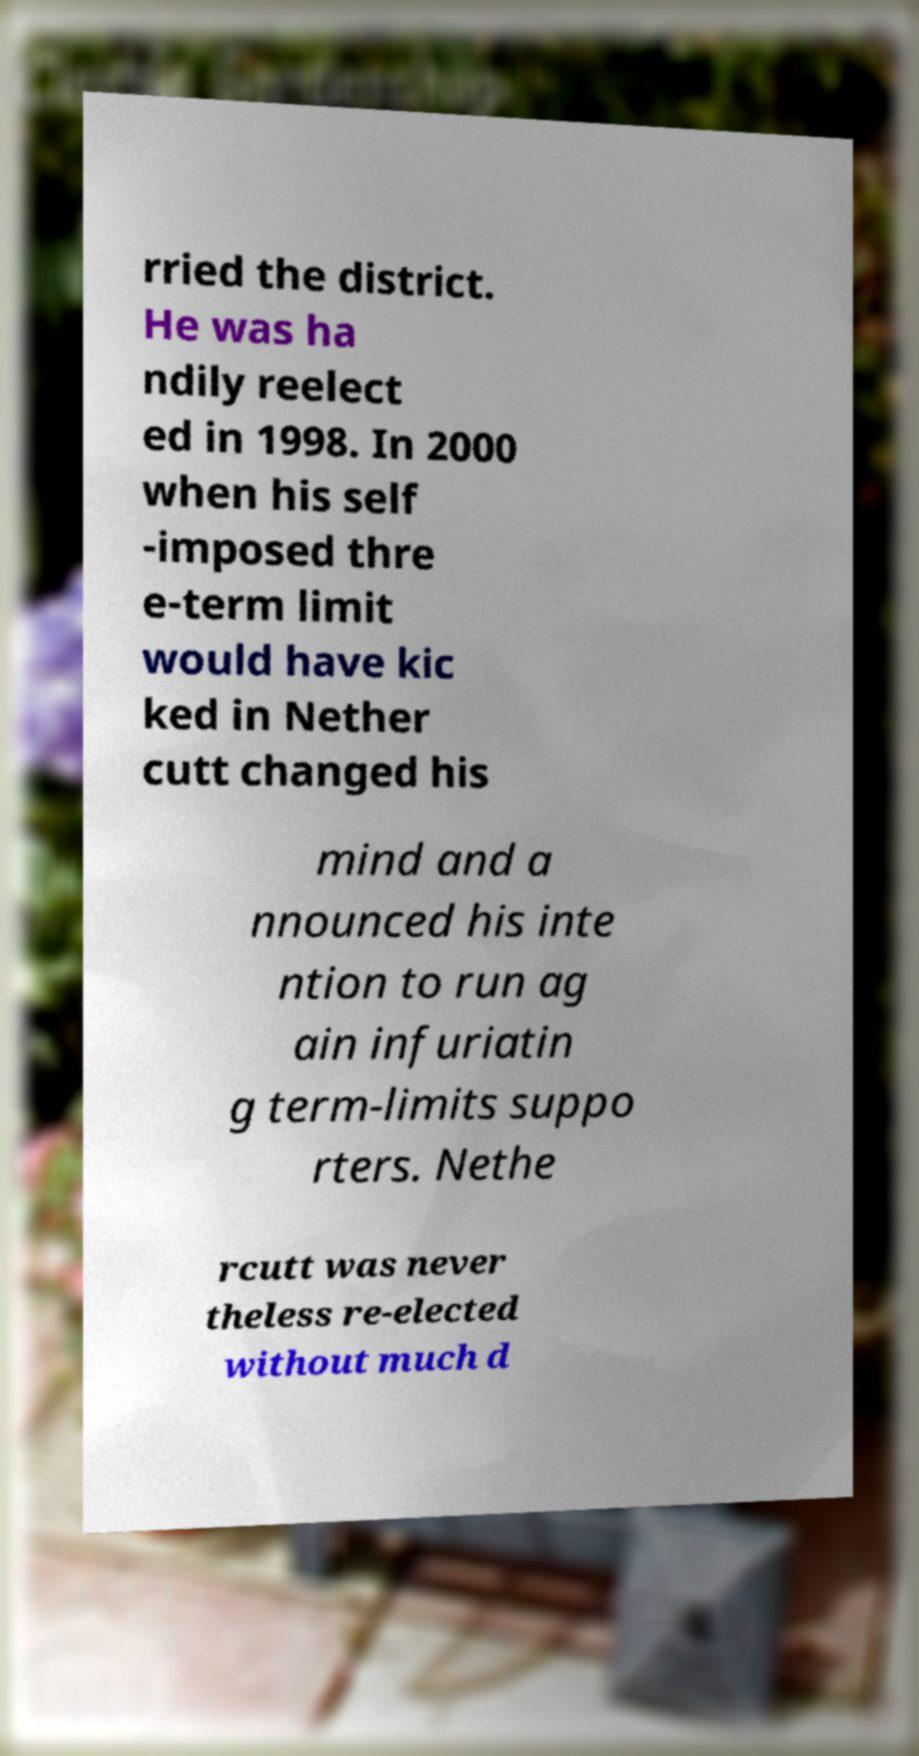What messages or text are displayed in this image? I need them in a readable, typed format. rried the district. He was ha ndily reelect ed in 1998. In 2000 when his self -imposed thre e-term limit would have kic ked in Nether cutt changed his mind and a nnounced his inte ntion to run ag ain infuriatin g term-limits suppo rters. Nethe rcutt was never theless re-elected without much d 